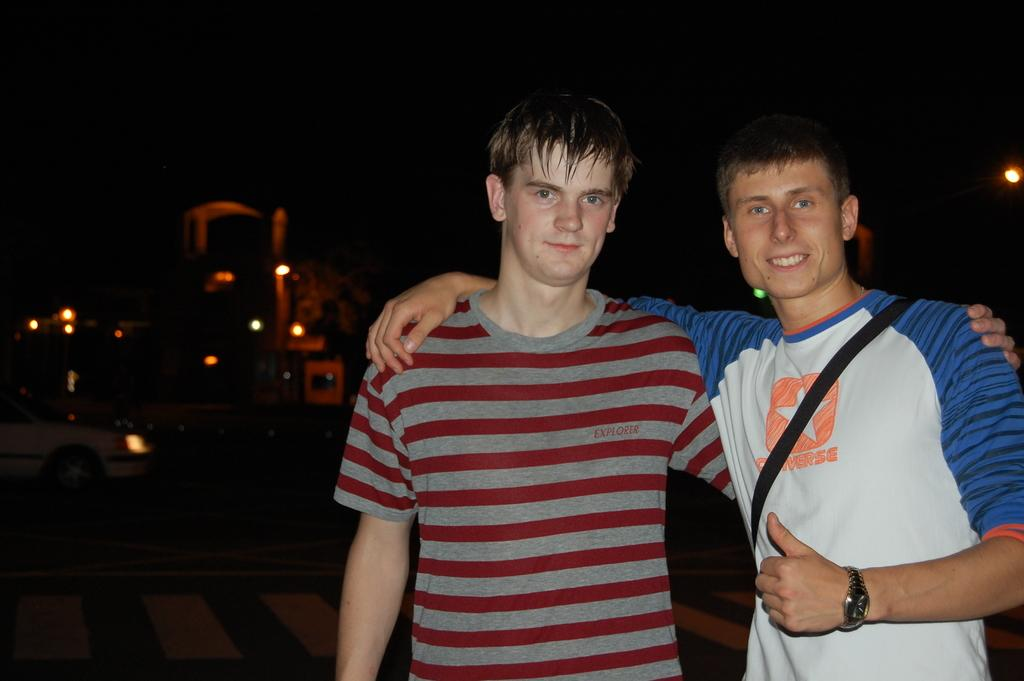<image>
Give a short and clear explanation of the subsequent image. A blue and white shirted man is posing for a pictue with a man in a gray and red shirt with the logo for Explorer on his chest. 